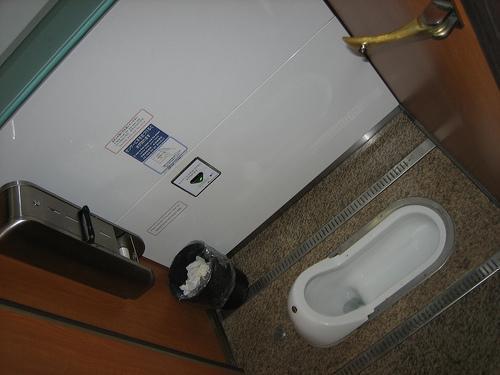How many trash cans are there?
Give a very brief answer. 1. 